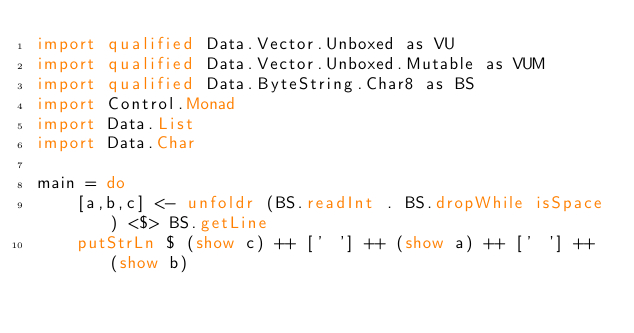<code> <loc_0><loc_0><loc_500><loc_500><_Haskell_>import qualified Data.Vector.Unboxed as VU
import qualified Data.Vector.Unboxed.Mutable as VUM
import qualified Data.ByteString.Char8 as BS
import Control.Monad
import Data.List
import Data.Char

main = do
    [a,b,c] <- unfoldr (BS.readInt . BS.dropWhile isSpace) <$> BS.getLine
    putStrLn $ (show c) ++ [' '] ++ (show a) ++ [' '] ++ (show b)</code> 